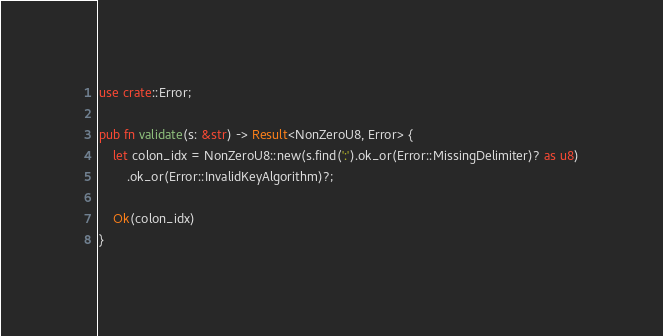Convert code to text. <code><loc_0><loc_0><loc_500><loc_500><_Rust_>
use crate::Error;

pub fn validate(s: &str) -> Result<NonZeroU8, Error> {
    let colon_idx = NonZeroU8::new(s.find(':').ok_or(Error::MissingDelimiter)? as u8)
        .ok_or(Error::InvalidKeyAlgorithm)?;

    Ok(colon_idx)
}
</code> 